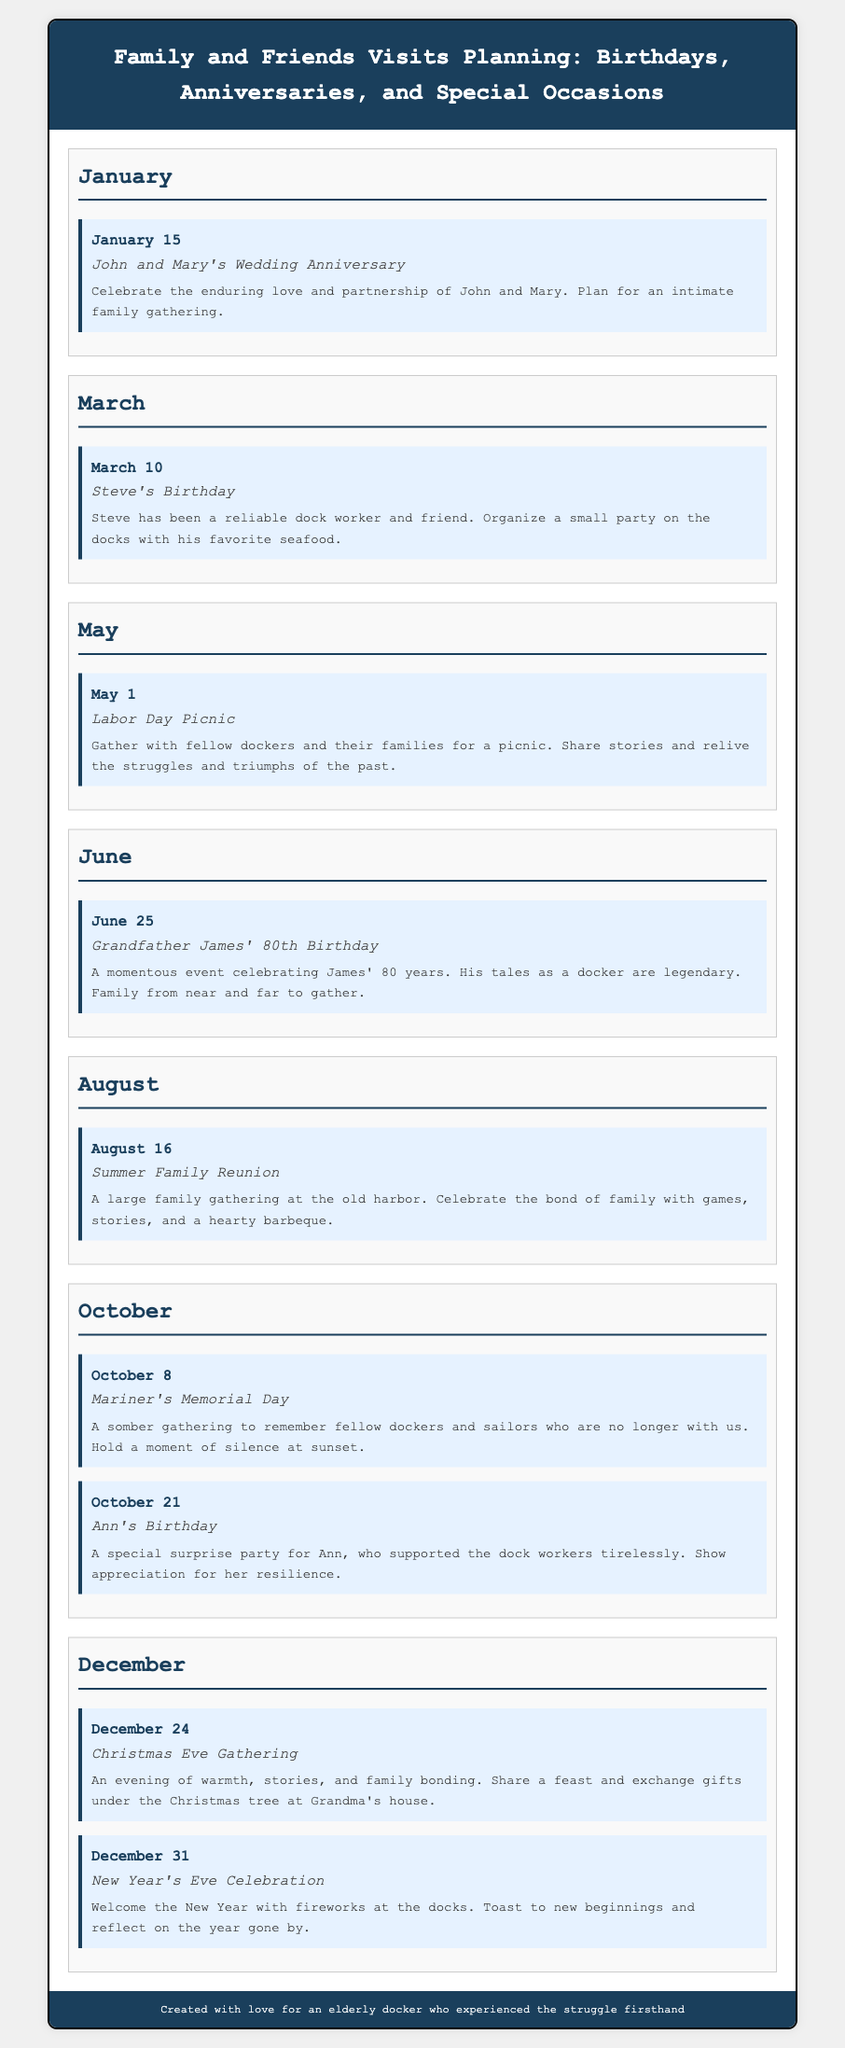What event is celebrated on January 15? The event celebrated on January 15 is John and Mary's Wedding Anniversary.
Answer: John and Mary's Wedding Anniversary What is the date of Steve's Birthday? The date of Steve's Birthday is March 10.
Answer: March 10 What significant birthday does Grandfather James celebrate in June? Grandfather James celebrates his 80th Birthday in June.
Answer: 80th Birthday What occasion is held on October 8? The occasion held on October 8 is Mariner's Memorial Day.
Answer: Mariner's Memorial Day How many events are scheduled in December? There are two events scheduled in December: Christmas Eve Gathering and New Year's Eve Celebration.
Answer: Two events Which month has a Labor Day Picnic? The month with a Labor Day Picnic is May.
Answer: May What kind of gathering is planned for August 16? A Summer Family Reunion is planned for August 16.
Answer: Summer Family Reunion What is the main activity for Christmas Eve Gathering? The main activity for Christmas Eve Gathering is sharing a feast and exchanging gifts.
Answer: Sharing a feast and exchanging gifts 